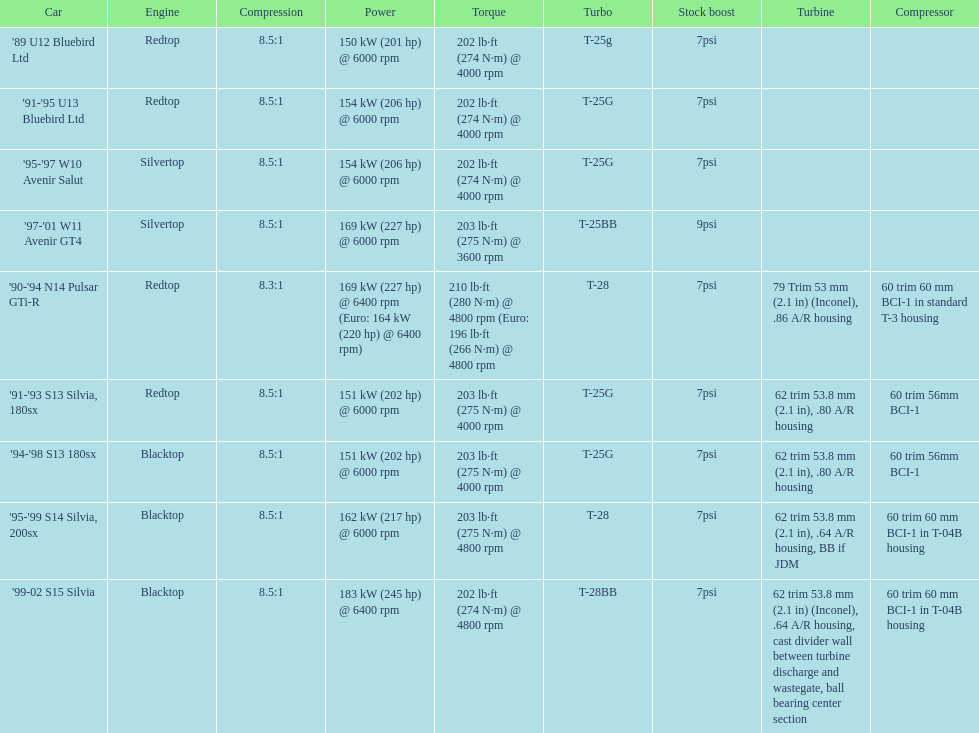In which car can you find the exclusive feature of having over 230 horsepower? '99-02 S15 Silvia. Can you parse all the data within this table? {'header': ['Car', 'Engine', 'Compression', 'Power', 'Torque', 'Turbo', 'Stock boost', 'Turbine', 'Compressor'], 'rows': [["'89 U12 Bluebird Ltd", 'Redtop', '8.5:1', '150\xa0kW (201\xa0hp) @ 6000 rpm', '202\xa0lb·ft (274\xa0N·m) @ 4000 rpm', 'T-25g', '7psi', '', ''], ["'91-'95 U13 Bluebird Ltd", 'Redtop', '8.5:1', '154\xa0kW (206\xa0hp) @ 6000 rpm', '202\xa0lb·ft (274\xa0N·m) @ 4000 rpm', 'T-25G', '7psi', '', ''], ["'95-'97 W10 Avenir Salut", 'Silvertop', '8.5:1', '154\xa0kW (206\xa0hp) @ 6000 rpm', '202\xa0lb·ft (274\xa0N·m) @ 4000 rpm', 'T-25G', '7psi', '', ''], ["'97-'01 W11 Avenir GT4", 'Silvertop', '8.5:1', '169\xa0kW (227\xa0hp) @ 6000 rpm', '203\xa0lb·ft (275\xa0N·m) @ 3600 rpm', 'T-25BB', '9psi', '', ''], ["'90-'94 N14 Pulsar GTi-R", 'Redtop', '8.3:1', '169\xa0kW (227\xa0hp) @ 6400 rpm (Euro: 164\xa0kW (220\xa0hp) @ 6400 rpm)', '210\xa0lb·ft (280\xa0N·m) @ 4800 rpm (Euro: 196\xa0lb·ft (266\xa0N·m) @ 4800 rpm', 'T-28', '7psi', '79 Trim 53\xa0mm (2.1\xa0in) (Inconel), .86 A/R housing', '60 trim 60\xa0mm BCI-1 in standard T-3 housing'], ["'91-'93 S13 Silvia, 180sx", 'Redtop', '8.5:1', '151\xa0kW (202\xa0hp) @ 6000 rpm', '203\xa0lb·ft (275\xa0N·m) @ 4000 rpm', 'T-25G', '7psi', '62 trim 53.8\xa0mm (2.1\xa0in), .80 A/R housing', '60 trim 56mm BCI-1'], ["'94-'98 S13 180sx", 'Blacktop', '8.5:1', '151\xa0kW (202\xa0hp) @ 6000 rpm', '203\xa0lb·ft (275\xa0N·m) @ 4000 rpm', 'T-25G', '7psi', '62 trim 53.8\xa0mm (2.1\xa0in), .80 A/R housing', '60 trim 56mm BCI-1'], ["'95-'99 S14 Silvia, 200sx", 'Blacktop', '8.5:1', '162\xa0kW (217\xa0hp) @ 6000 rpm', '203\xa0lb·ft (275\xa0N·m) @ 4800 rpm', 'T-28', '7psi', '62 trim 53.8\xa0mm (2.1\xa0in), .64 A/R housing, BB if JDM', '60 trim 60\xa0mm BCI-1 in T-04B housing'], ["'99-02 S15 Silvia", 'Blacktop', '8.5:1', '183\xa0kW (245\xa0hp) @ 6400 rpm', '202\xa0lb·ft (274\xa0N·m) @ 4800 rpm', 'T-28BB', '7psi', '62 trim 53.8\xa0mm (2.1\xa0in) (Inconel), .64 A/R housing, cast divider wall between turbine discharge and wastegate, ball bearing center section', '60 trim 60\xa0mm BCI-1 in T-04B housing']]} 